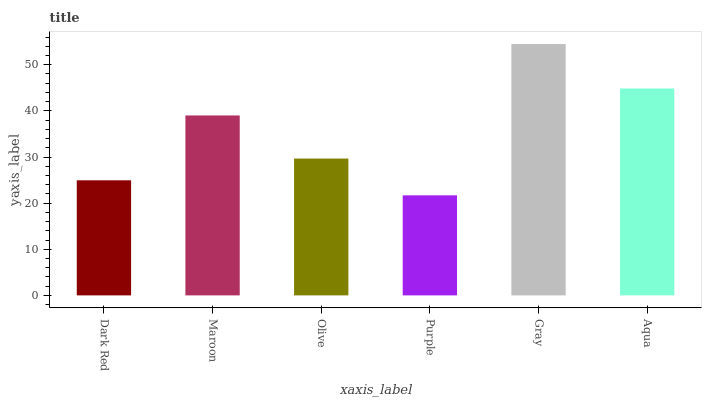Is Purple the minimum?
Answer yes or no. Yes. Is Gray the maximum?
Answer yes or no. Yes. Is Maroon the minimum?
Answer yes or no. No. Is Maroon the maximum?
Answer yes or no. No. Is Maroon greater than Dark Red?
Answer yes or no. Yes. Is Dark Red less than Maroon?
Answer yes or no. Yes. Is Dark Red greater than Maroon?
Answer yes or no. No. Is Maroon less than Dark Red?
Answer yes or no. No. Is Maroon the high median?
Answer yes or no. Yes. Is Olive the low median?
Answer yes or no. Yes. Is Olive the high median?
Answer yes or no. No. Is Dark Red the low median?
Answer yes or no. No. 